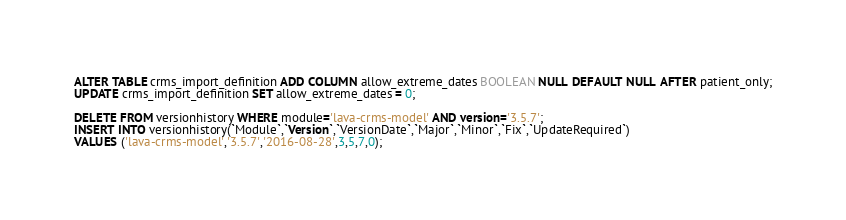Convert code to text. <code><loc_0><loc_0><loc_500><loc_500><_SQL_>ALTER TABLE crms_import_definition ADD COLUMN allow_extreme_dates BOOLEAN NULL DEFAULT NULL AFTER patient_only;
UPDATE crms_import_definition SET allow_extreme_dates = 0;

DELETE FROM versionhistory WHERE module='lava-crms-model' AND version='3.5.7';
INSERT INTO versionhistory(`Module`,`Version`,`VersionDate`,`Major`,`Minor`,`Fix`,`UpdateRequired`)
VALUES ('lava-crms-model','3.5.7','2016-08-28',3,5,7,0);


</code> 